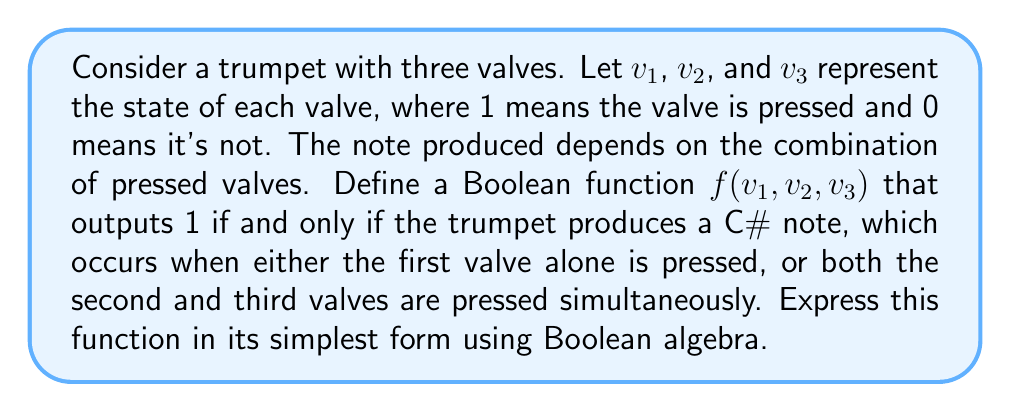Can you solve this math problem? Let's approach this step-by-step:

1) We need to create a function that outputs 1 in two cases:
   a) When only the first valve is pressed: $v_1 = 1, v_2 = 0, v_3 = 0$
   b) When both the second and third valves are pressed: $v_1 = 0, v_2 = 1, v_3 = 1$

2) We can express these conditions using Boolean algebra:
   a) $v_1 \cdot \overline{v_2} \cdot \overline{v_3}$
   b) $\overline{v_1} \cdot v_2 \cdot v_3$

3) The function $f$ should output 1 if either of these conditions is true. In Boolean algebra, "or" is represented by addition (+). So our initial function is:

   $$f(v_1, v_2, v_3) = (v_1 \cdot \overline{v_2} \cdot \overline{v_3}) + (\overline{v_1} \cdot v_2 \cdot v_3)$$

4) This is already in its simplest form, as there are no common terms that can be factored out or simplified further using Boolean algebra laws.
Answer: $f(v_1, v_2, v_3) = (v_1 \cdot \overline{v_2} \cdot \overline{v_3}) + (\overline{v_1} \cdot v_2 \cdot v_3)$ 